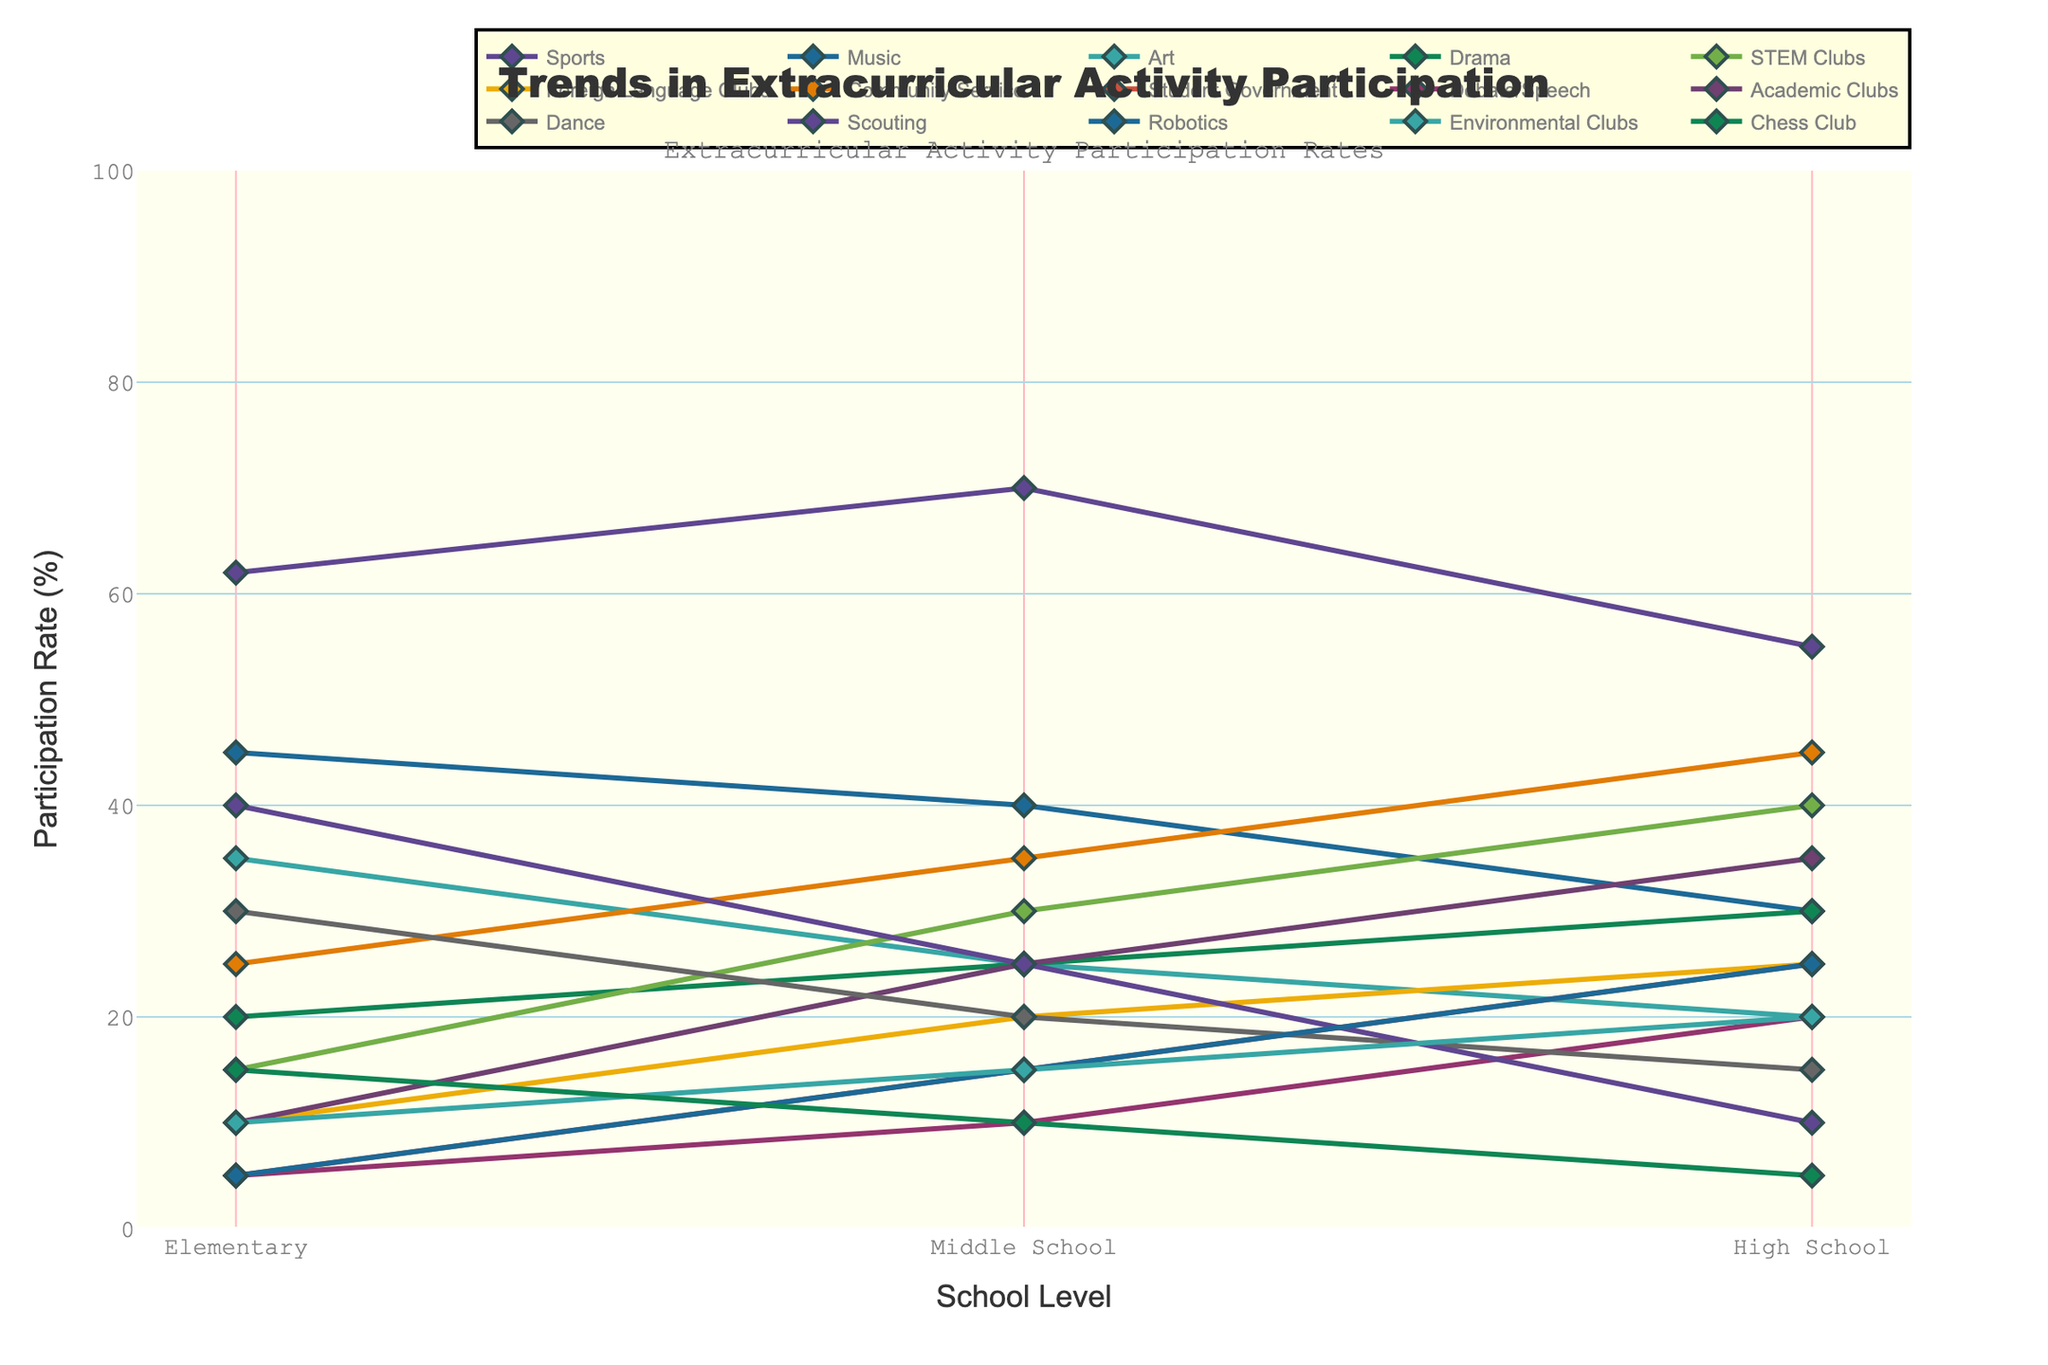Which activity has the highest participation rate in Elementary? The highest point on the Y-axis corresponding to the Elementary school level is 62%, which is for Sports.
Answer: Sports Which activity's participation rate decreases the most from Middle School to High School? Community Service shows a significant decrease from 35% in Middle School to 45% in High School, but Scouting decreases the most from 25% to 10% (a difference of 15%).
Answer: Scouting What is the average participation rate of STEM Clubs across all school levels? The participation rates for STEM Clubs are 15% (Elementary), 30% (Middle School), and 40% (High School). Sum = 15 + 30 + 40 = 85. Average = 85 / 3 = 28.3 (approx).
Answer: 28.3% Which activities have increasing participation from Elementary to High School? By viewing the trends, Drama, STEM Clubs, Foreign Language Clubs, Community Service, Student Government, Debate/Speech, Academic Clubs, and Robotics show an increasing trend from Elementary to High School.
Answer: Drama, STEM Clubs, Foreign Language Clubs, Community Service, Student Government, Debate/Speech, Academic Clubs, Robotics Compare the participation rates of Art and Dance in High School. Which is higher? At the High School level, Art has a participation rate of 20%, while Dance has a rate of 15%. Therefore, Art is higher.
Answer: Art What's the difference in participation rates between Sports and Music in Middle School? The participation rate for Sports in Middle School is 70%, and for Music, it is 40%. Difference = 70 - 40 = 30.
Answer: 30% Identify the activity with the lowest participation rate in High School. The lowest point on the Y-axis corresponding to the High School level is 5%, which is for Chess Club.
Answer: Chess Club Which three activities have the smallest overall change in participation rates across all school levels? Chess Club varies from 15% to 5%, Debate/Speech from 5% to 20%, and Music from 45% to 30%. These show smaller ranges, with Chess Club having the smallest.
Answer: Chess Club, Debate/Speech, Music What is the sum of participation rates of Student Government and Debate/Speech in High School? The participation rate for Student Government in High School is 25%, and for Debate/Speech, it is 20%. Sum = 25 + 20 = 45.
Answer: 45% Does Robotics have a higher participation rate than Environmental Clubs in Middle School? Viewing the rates in Middle School, Robotics has 15%, while Environmental Clubs have 15%. The rates are equal.
Answer: No 